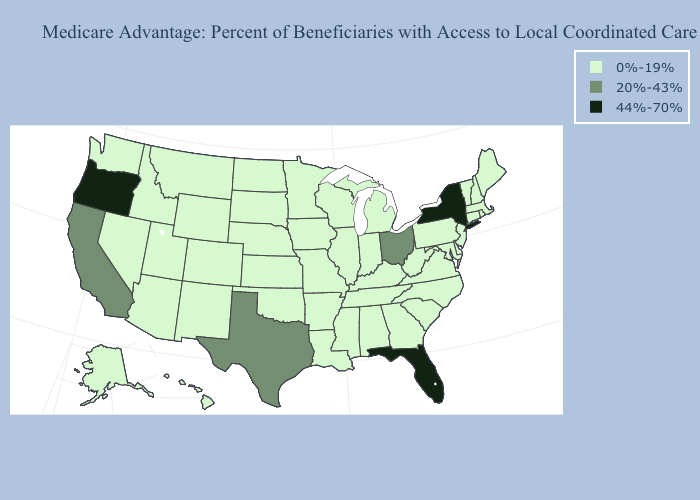Name the states that have a value in the range 0%-19%?
Keep it brief. Alaska, Alabama, Arkansas, Arizona, Colorado, Connecticut, Delaware, Georgia, Hawaii, Iowa, Idaho, Illinois, Indiana, Kansas, Kentucky, Louisiana, Massachusetts, Maryland, Maine, Michigan, Minnesota, Missouri, Mississippi, Montana, North Carolina, North Dakota, Nebraska, New Hampshire, New Jersey, New Mexico, Nevada, Oklahoma, Pennsylvania, Rhode Island, South Carolina, South Dakota, Tennessee, Utah, Virginia, Vermont, Washington, Wisconsin, West Virginia, Wyoming. Does Texas have the lowest value in the South?
Be succinct. No. What is the value of Utah?
Write a very short answer. 0%-19%. Name the states that have a value in the range 44%-70%?
Be succinct. Florida, New York, Oregon. Which states have the lowest value in the USA?
Write a very short answer. Alaska, Alabama, Arkansas, Arizona, Colorado, Connecticut, Delaware, Georgia, Hawaii, Iowa, Idaho, Illinois, Indiana, Kansas, Kentucky, Louisiana, Massachusetts, Maryland, Maine, Michigan, Minnesota, Missouri, Mississippi, Montana, North Carolina, North Dakota, Nebraska, New Hampshire, New Jersey, New Mexico, Nevada, Oklahoma, Pennsylvania, Rhode Island, South Carolina, South Dakota, Tennessee, Utah, Virginia, Vermont, Washington, Wisconsin, West Virginia, Wyoming. What is the highest value in the USA?
Concise answer only. 44%-70%. Name the states that have a value in the range 0%-19%?
Keep it brief. Alaska, Alabama, Arkansas, Arizona, Colorado, Connecticut, Delaware, Georgia, Hawaii, Iowa, Idaho, Illinois, Indiana, Kansas, Kentucky, Louisiana, Massachusetts, Maryland, Maine, Michigan, Minnesota, Missouri, Mississippi, Montana, North Carolina, North Dakota, Nebraska, New Hampshire, New Jersey, New Mexico, Nevada, Oklahoma, Pennsylvania, Rhode Island, South Carolina, South Dakota, Tennessee, Utah, Virginia, Vermont, Washington, Wisconsin, West Virginia, Wyoming. Does the map have missing data?
Answer briefly. No. Does Washington have the same value as Oregon?
Give a very brief answer. No. Does Oregon have the highest value in the USA?
Write a very short answer. Yes. Does New York have the lowest value in the Northeast?
Be succinct. No. Does the first symbol in the legend represent the smallest category?
Give a very brief answer. Yes. What is the value of Tennessee?
Quick response, please. 0%-19%. Is the legend a continuous bar?
Quick response, please. No. Does Ohio have the lowest value in the USA?
Give a very brief answer. No. 